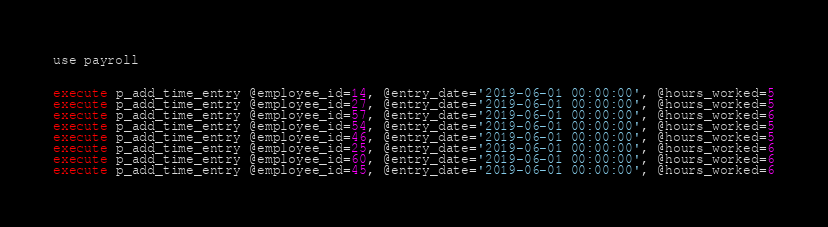Convert code to text. <code><loc_0><loc_0><loc_500><loc_500><_SQL_>use payroll


execute p_add_time_entry @employee_id=14, @entry_date='2019-06-01 00:00:00', @hours_worked=5
execute p_add_time_entry @employee_id=27, @entry_date='2019-06-01 00:00:00', @hours_worked=5
execute p_add_time_entry @employee_id=57, @entry_date='2019-06-01 00:00:00', @hours_worked=6
execute p_add_time_entry @employee_id=54, @entry_date='2019-06-01 00:00:00', @hours_worked=5
execute p_add_time_entry @employee_id=46, @entry_date='2019-06-01 00:00:00', @hours_worked=5
execute p_add_time_entry @employee_id=25, @entry_date='2019-06-01 00:00:00', @hours_worked=6
execute p_add_time_entry @employee_id=60, @entry_date='2019-06-01 00:00:00', @hours_worked=6
execute p_add_time_entry @employee_id=45, @entry_date='2019-06-01 00:00:00', @hours_worked=6

</code> 